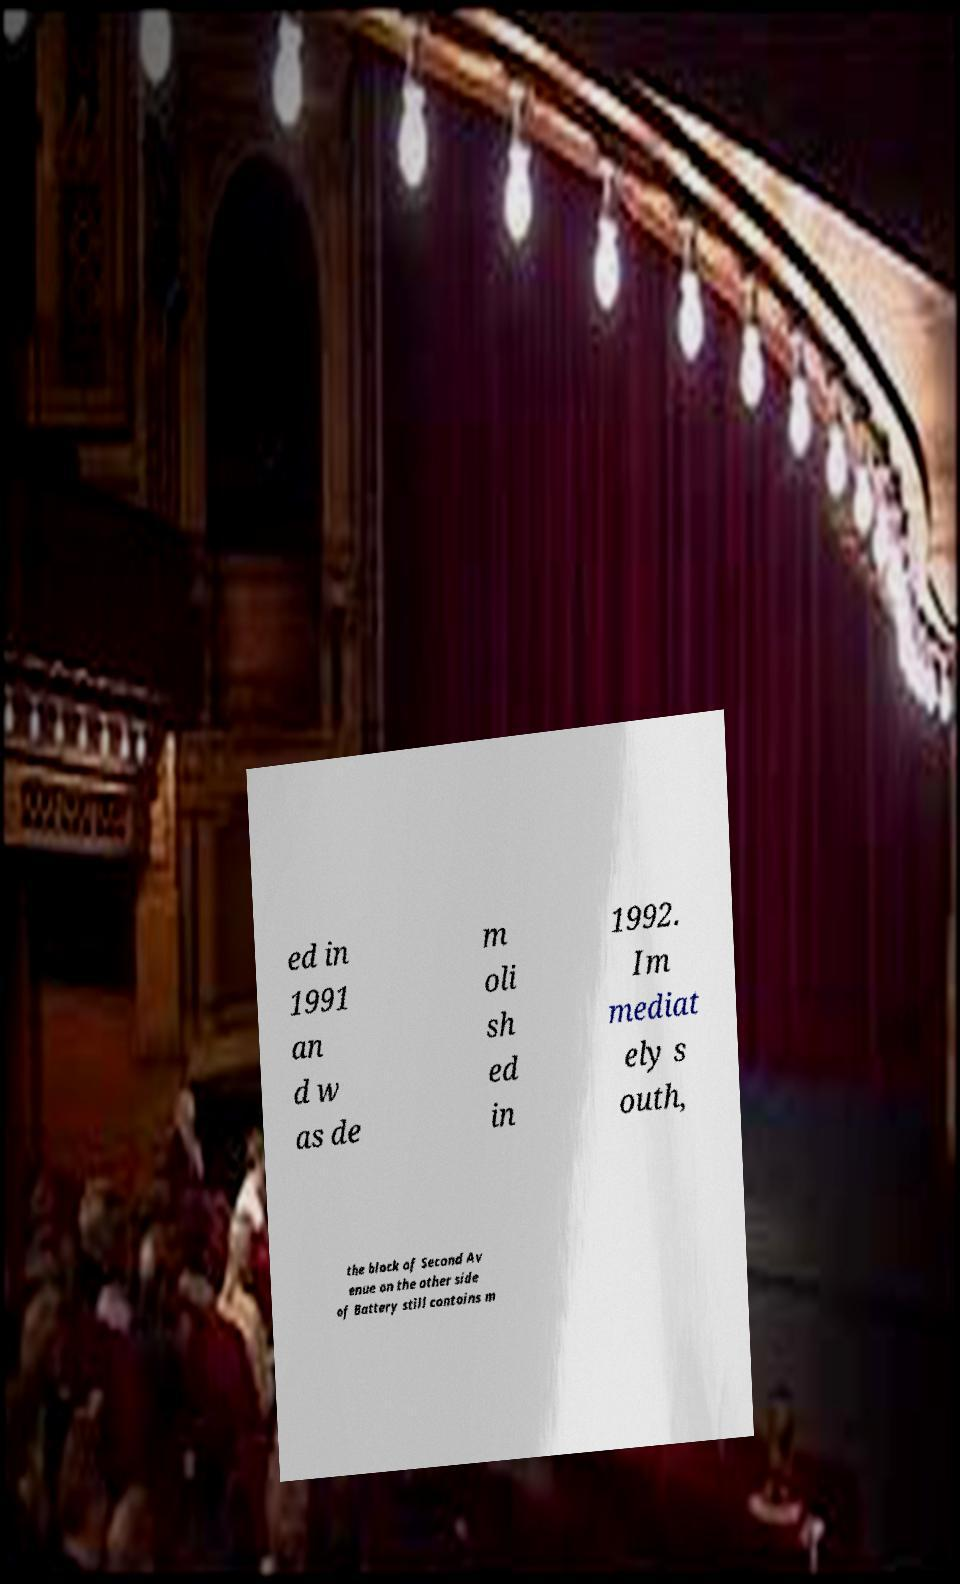What messages or text are displayed in this image? I need them in a readable, typed format. ed in 1991 an d w as de m oli sh ed in 1992. Im mediat ely s outh, the block of Second Av enue on the other side of Battery still contains m 